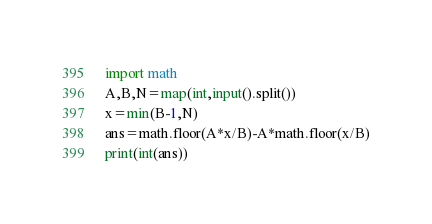Convert code to text. <code><loc_0><loc_0><loc_500><loc_500><_Python_>import math
A,B,N=map(int,input().split())
x=min(B-1,N)
ans=math.floor(A*x/B)-A*math.floor(x/B)
print(int(ans))

</code> 